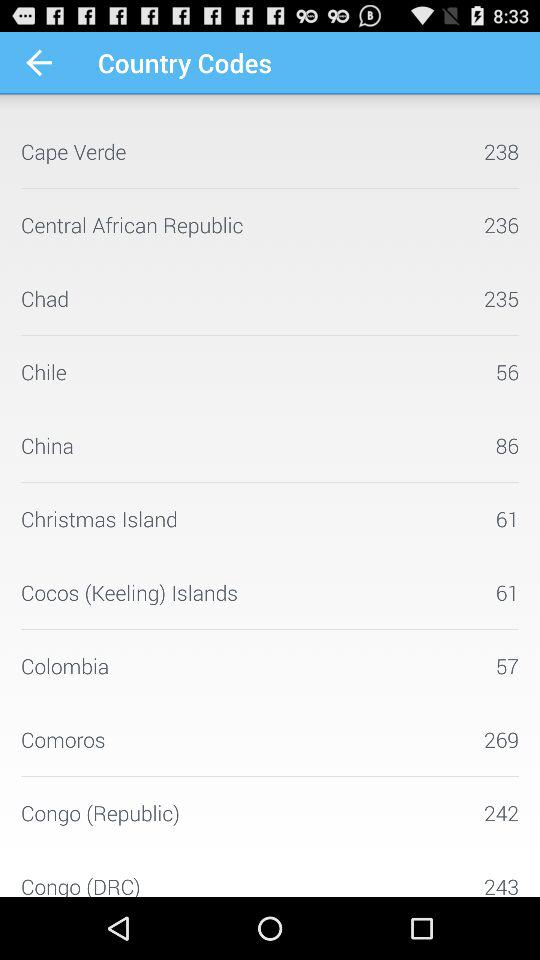What is the name of the country having a country code of 235? The name of the country that has a country code of 235 is Chad. 